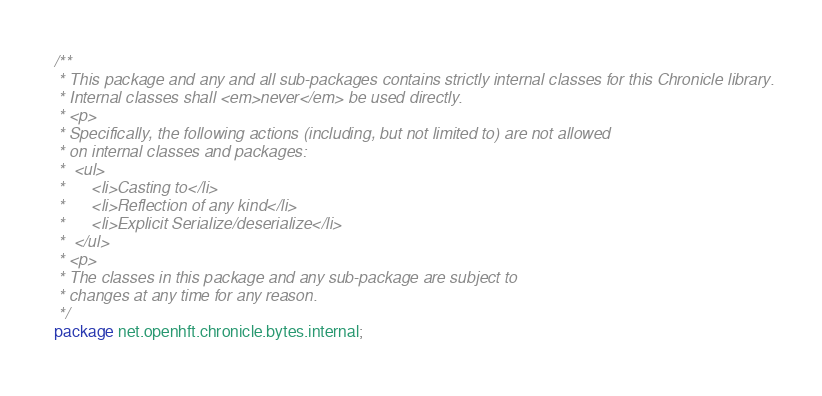<code> <loc_0><loc_0><loc_500><loc_500><_Java_>/**
 * This package and any and all sub-packages contains strictly internal classes for this Chronicle library.
 * Internal classes shall <em>never</em> be used directly.
 * <p>
 * Specifically, the following actions (including, but not limited to) are not allowed
 * on internal classes and packages:
 *  <ul>
 *      <li>Casting to</li>
 *      <li>Reflection of any kind</li>
 *      <li>Explicit Serialize/deserialize</li>
 *  </ul>
 * <p>
 * The classes in this package and any sub-package are subject to
 * changes at any time for any reason.
 */
package net.openhft.chronicle.bytes.internal;
</code> 